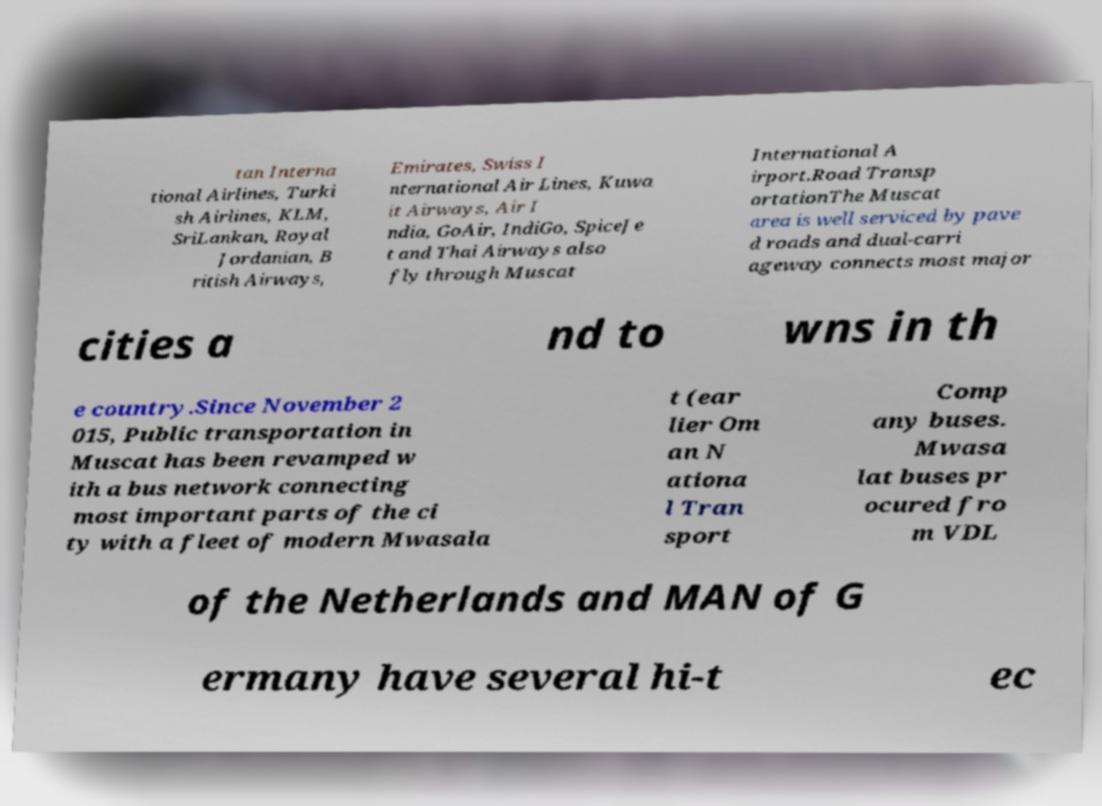What messages or text are displayed in this image? I need them in a readable, typed format. tan Interna tional Airlines, Turki sh Airlines, KLM, SriLankan, Royal Jordanian, B ritish Airways, Emirates, Swiss I nternational Air Lines, Kuwa it Airways, Air I ndia, GoAir, IndiGo, SpiceJe t and Thai Airways also fly through Muscat International A irport.Road Transp ortationThe Muscat area is well serviced by pave d roads and dual-carri ageway connects most major cities a nd to wns in th e country.Since November 2 015, Public transportation in Muscat has been revamped w ith a bus network connecting most important parts of the ci ty with a fleet of modern Mwasala t (ear lier Om an N ationa l Tran sport Comp any buses. Mwasa lat buses pr ocured fro m VDL of the Netherlands and MAN of G ermany have several hi-t ec 